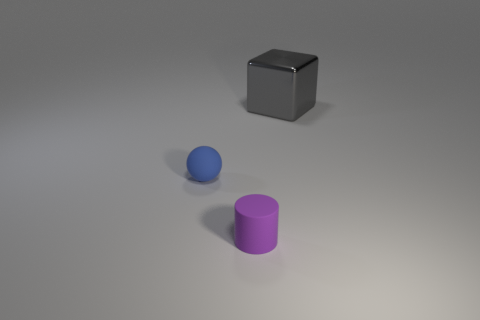Add 3 small blue matte spheres. How many objects exist? 6 Subtract all spheres. How many objects are left? 2 Subtract 0 blue cylinders. How many objects are left? 3 Subtract all tiny cyan shiny objects. Subtract all small purple objects. How many objects are left? 2 Add 3 blocks. How many blocks are left? 4 Add 3 tiny blue spheres. How many tiny blue spheres exist? 4 